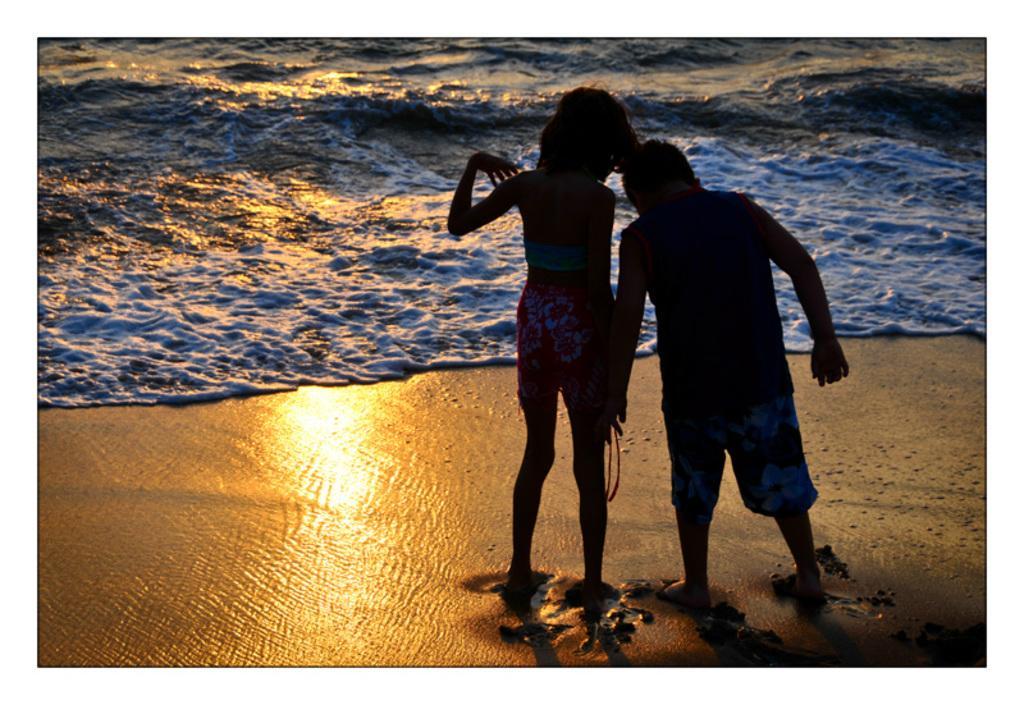Could you give a brief overview of what you see in this image? In this image I can see the sea , in front of the sea I can see a boy and girl and a light focus visible at the bottom. 